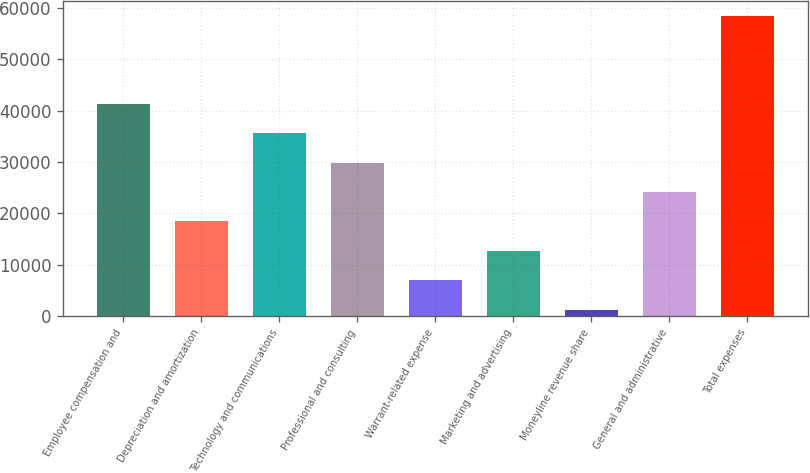<chart> <loc_0><loc_0><loc_500><loc_500><bar_chart><fcel>Employee compensation and<fcel>Depreciation and amortization<fcel>Technology and communications<fcel>Professional and consulting<fcel>Warrant-related expense<fcel>Marketing and advertising<fcel>Moneyline revenue share<fcel>General and administrative<fcel>Total expenses<nl><fcel>41308.7<fcel>18412.3<fcel>35584.6<fcel>29860.5<fcel>6964.1<fcel>12688.2<fcel>1240<fcel>24136.4<fcel>58481<nl></chart> 